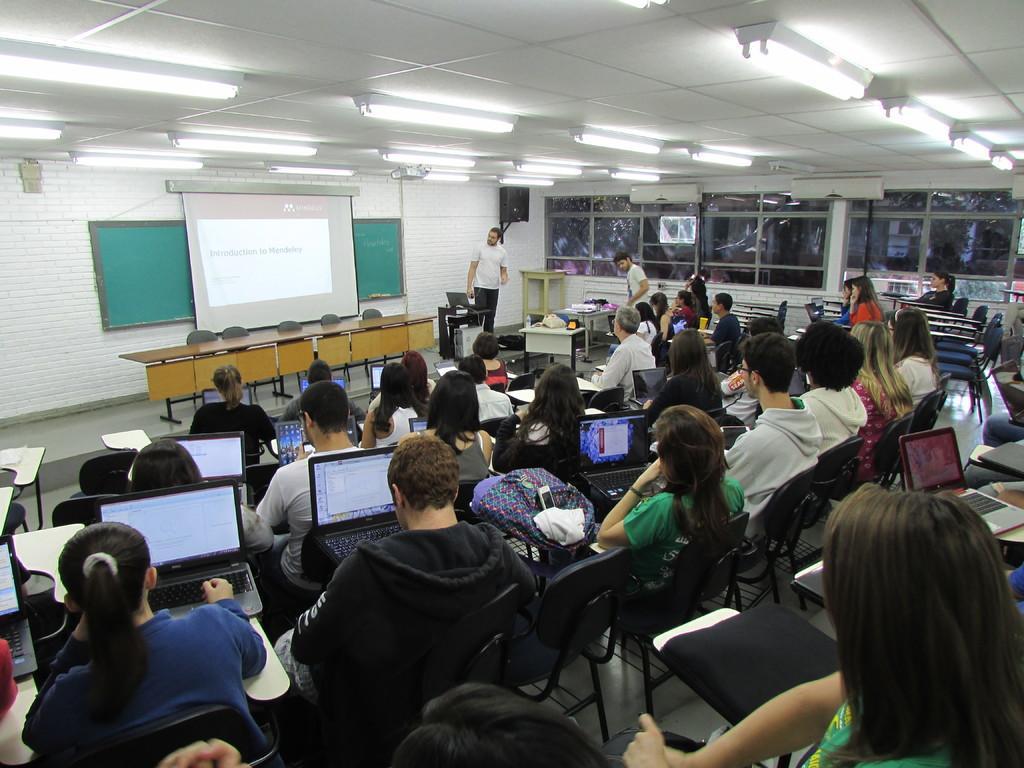Could you give a brief overview of what you see in this image? In this image there are group of people sitting on chairs, and they are looking into laptops. And in the center there is a screen and board, and on the right side there are some glass windows. And in the center there is one person who is standing, and at the top there is ceiling and some lights and at the bottom there is floor. 